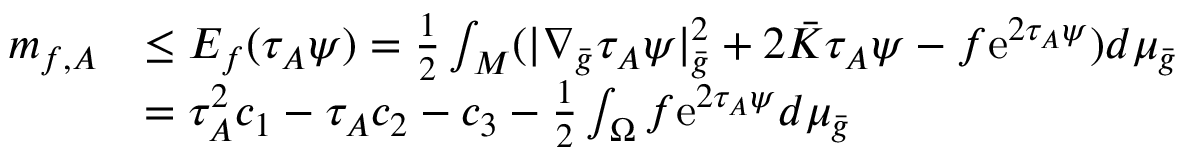Convert formula to latex. <formula><loc_0><loc_0><loc_500><loc_500>\begin{array} { r l } { m _ { f , A } } & { \leq E _ { f } ( \tau _ { A } \psi ) = \frac { 1 } { 2 } \int _ { M } ( | \nabla _ { \bar { g } } \tau _ { A } \psi | _ { \bar { g } } ^ { 2 } + 2 \bar { K } \tau _ { A } \psi - f e ^ { 2 \tau _ { A } \psi } ) d \mu _ { \bar { g } } } \\ & { = \tau _ { A } ^ { 2 } c _ { 1 } - \tau _ { A } c _ { 2 } - c _ { 3 } - \frac { 1 } { 2 } \int _ { \Omega } f e ^ { 2 \tau _ { A } \psi } d \mu _ { \bar { g } } } \end{array}</formula> 